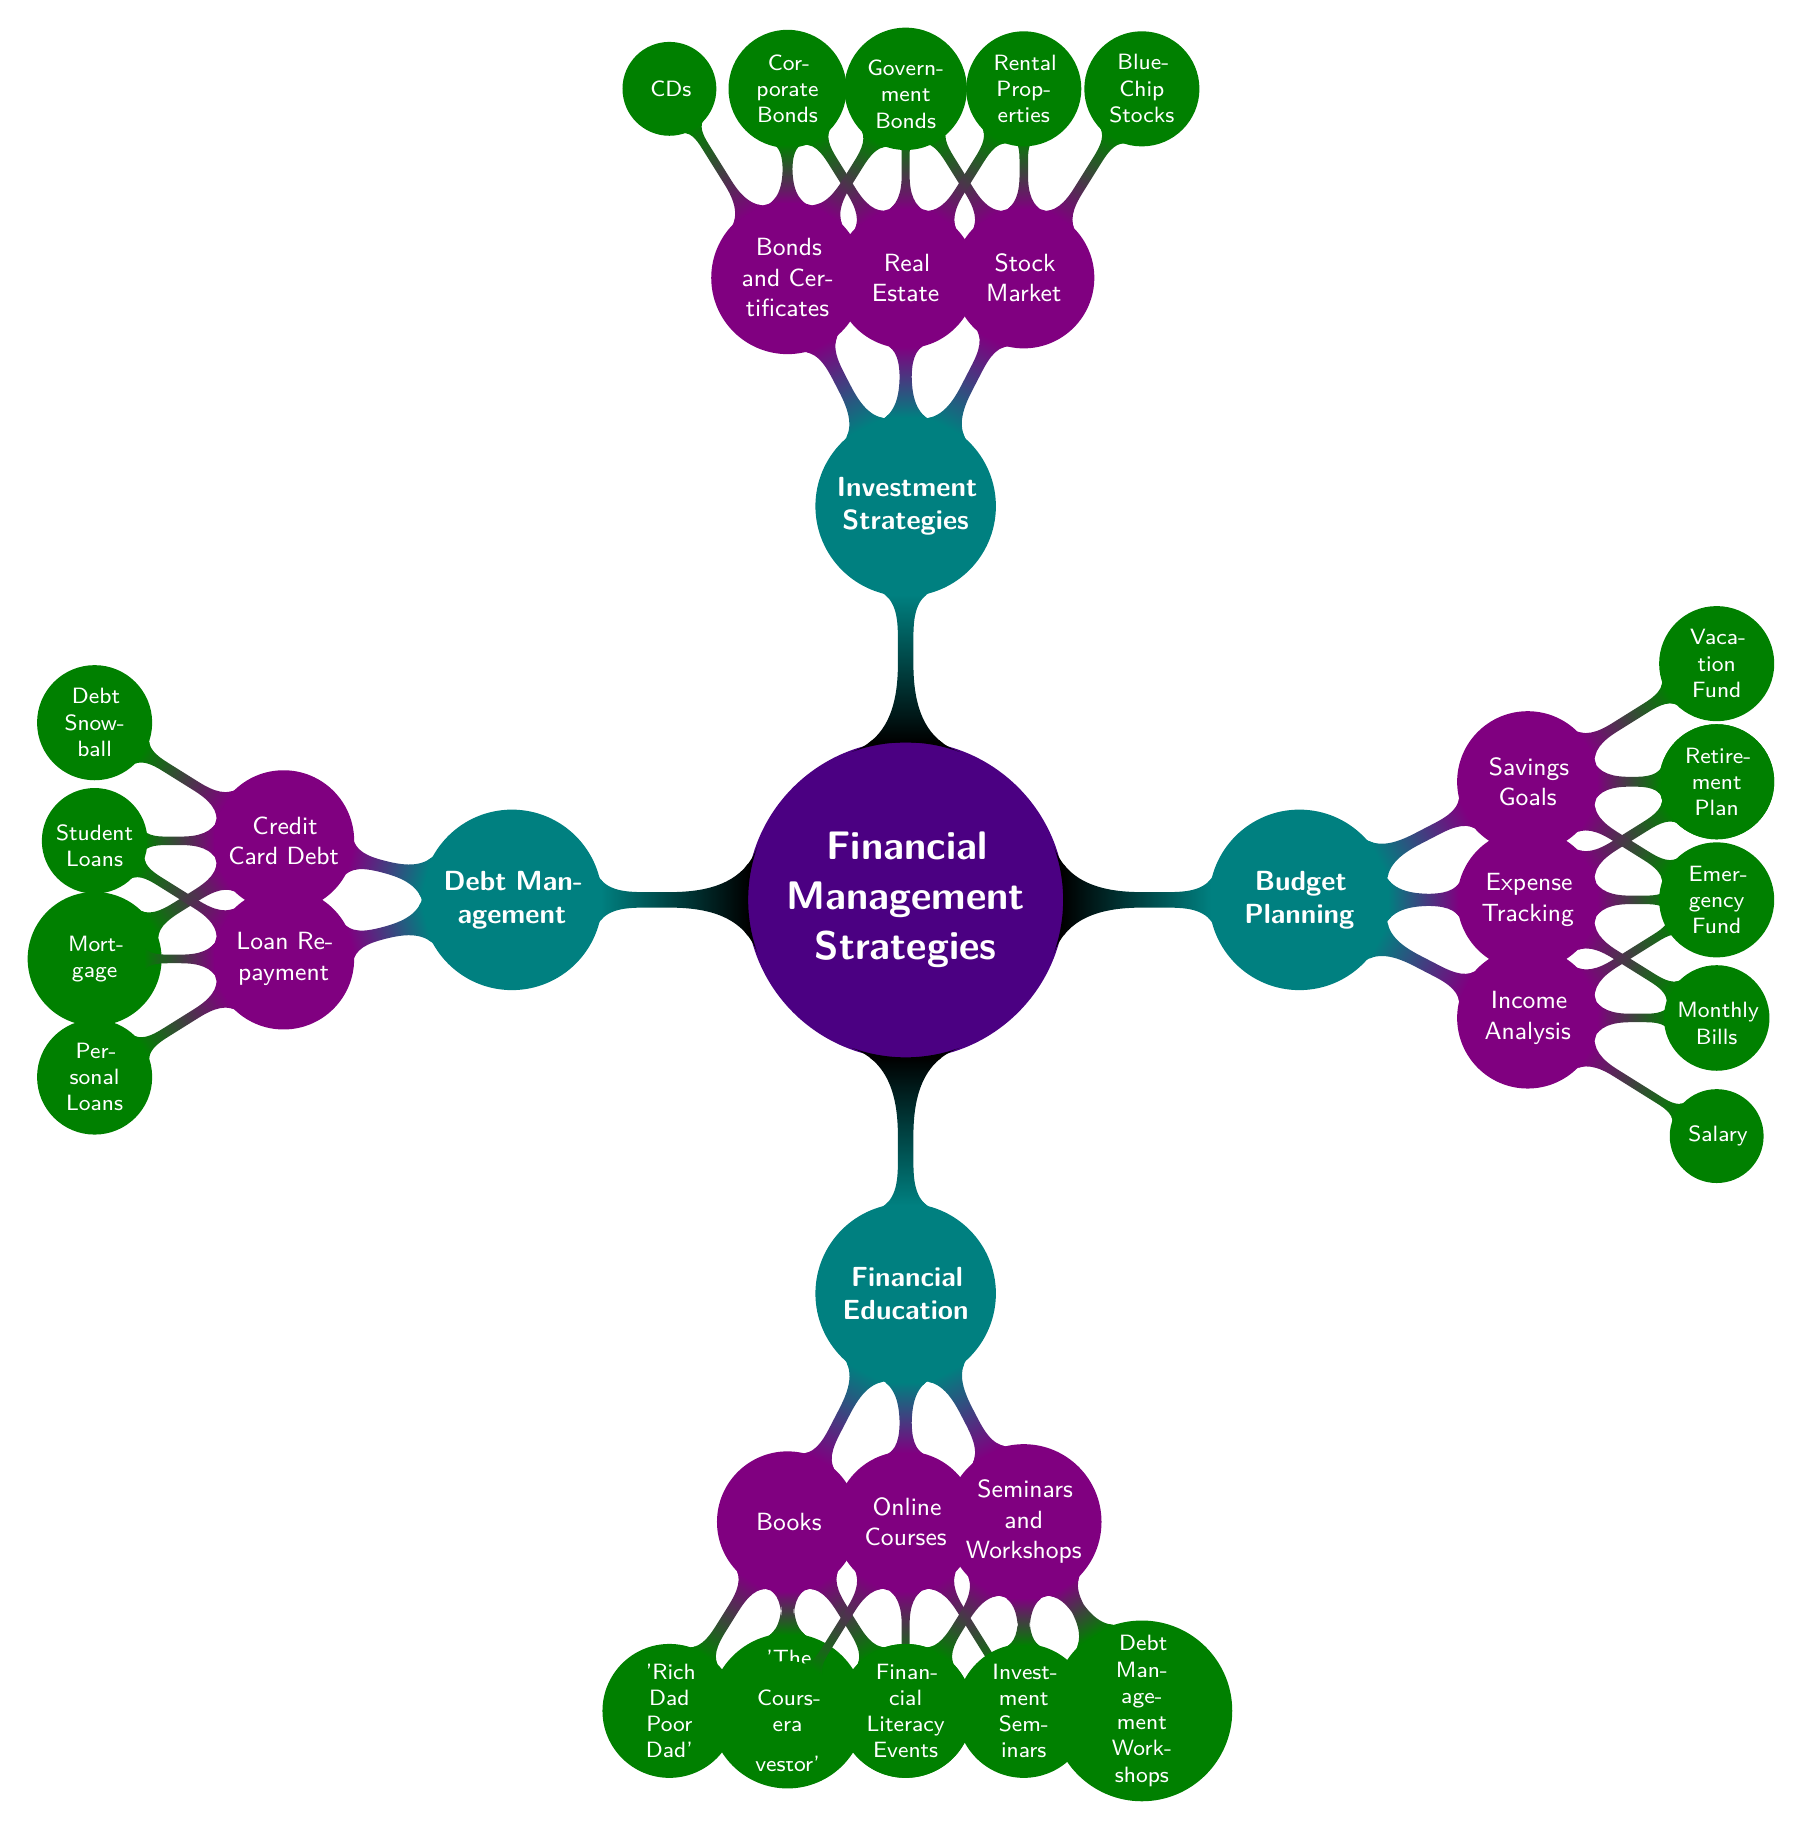What are the main topics in the mind map? The central topic is "Financial Management Strategies from the Coach." The main topics branching from it are "Budget Planning," "Investment Strategies," "Debt Management," and "Financial Education."
Answer: Budget Planning, Investment Strategies, Debt Management, Financial Education How many subtopics are there under 'Budget Planning'? Under 'Budget Planning,' there are three subtopics: "Income Analysis," "Expense Tracking," and "Savings Goals." Thus, the total is three.
Answer: 3 Which subtopic under 'Investment Strategies' focuses on rental income? The subtopic that focuses on rental income is "Real Estate."
Answer: Real Estate What is the total number of detail items listed under 'Debt Management'? Under 'Debt Management,' there are two subtopics: "Credit Card Debt" (with three details) and "Loan Repayment" (with three details). Therefore, 3 plus 3 equals 6.
Answer: 6 What type of financial education resources is available in the mind map? The resources listed for financial education are "Books," "Online Courses," and "Seminars and Workshops."
Answer: Books, Online Courses, Seminars and Workshops Which strategy under 'Debt Management' includes 'Debt Snowball'? The strategy that includes 'Debt Snowball' is under the subtopic "Credit Card Debt."
Answer: Credit Card Debt How many investment strategies are listed in the mind map? There are three main investment strategies listed: "Stock Market," "Real Estate," and "Bonds and Certificates." Therefore, the total is three.
Answer: 3 Which book is a recommended resource for financial education? One recommended book for financial education is "'Rich Dad Poor Dad'."
Answer: 'Rich Dad Poor Dad' 